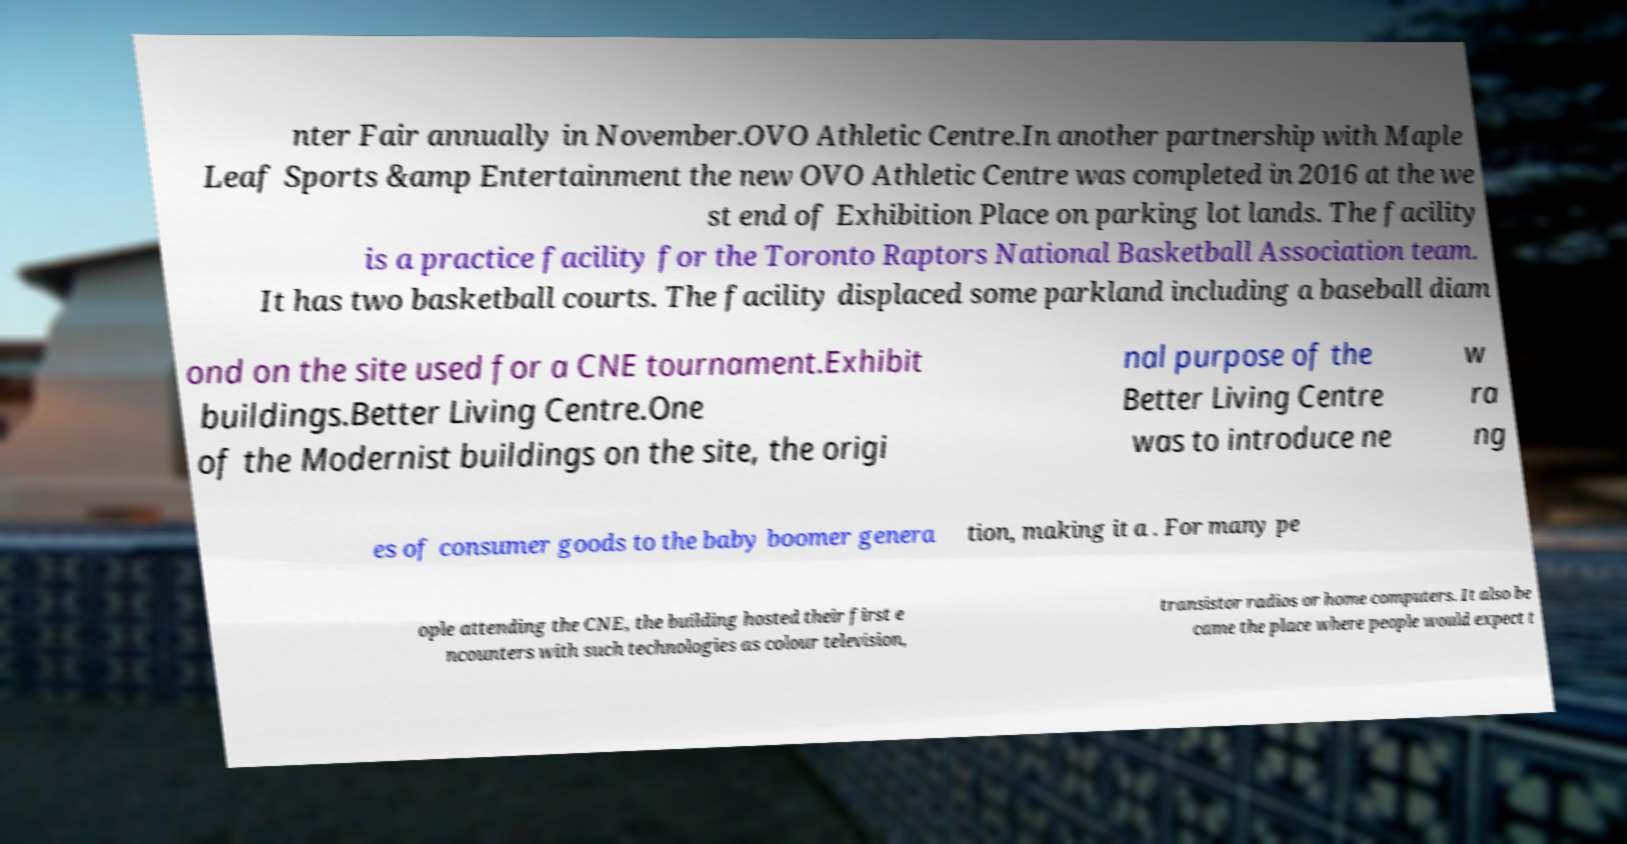Please read and relay the text visible in this image. What does it say? nter Fair annually in November.OVO Athletic Centre.In another partnership with Maple Leaf Sports &amp Entertainment the new OVO Athletic Centre was completed in 2016 at the we st end of Exhibition Place on parking lot lands. The facility is a practice facility for the Toronto Raptors National Basketball Association team. It has two basketball courts. The facility displaced some parkland including a baseball diam ond on the site used for a CNE tournament.Exhibit buildings.Better Living Centre.One of the Modernist buildings on the site, the origi nal purpose of the Better Living Centre was to introduce ne w ra ng es of consumer goods to the baby boomer genera tion, making it a . For many pe ople attending the CNE, the building hosted their first e ncounters with such technologies as colour television, transistor radios or home computers. It also be came the place where people would expect t 